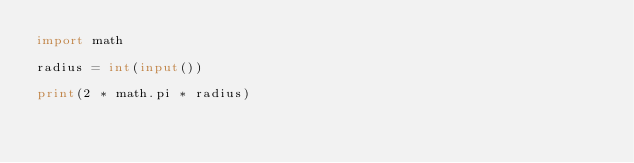Convert code to text. <code><loc_0><loc_0><loc_500><loc_500><_Python_>import math

radius = int(input())

print(2 * math.pi * radius)</code> 